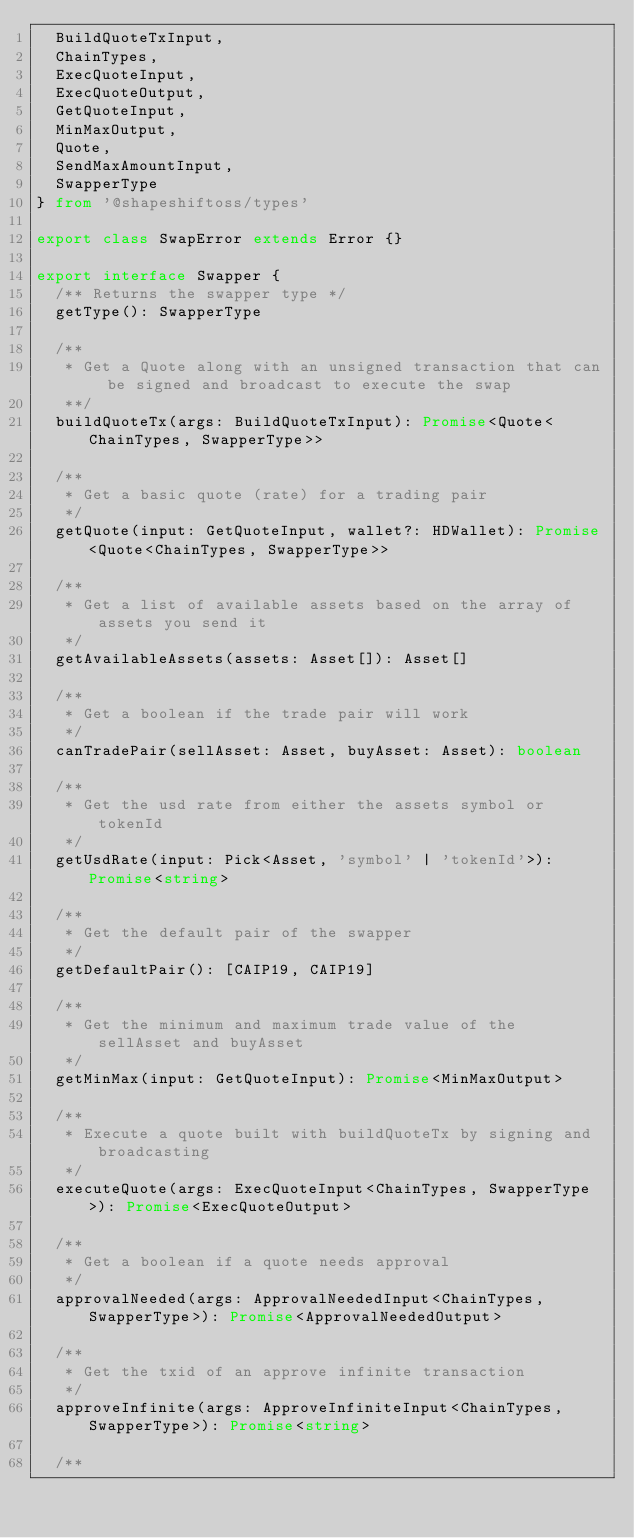<code> <loc_0><loc_0><loc_500><loc_500><_TypeScript_>  BuildQuoteTxInput,
  ChainTypes,
  ExecQuoteInput,
  ExecQuoteOutput,
  GetQuoteInput,
  MinMaxOutput,
  Quote,
  SendMaxAmountInput,
  SwapperType
} from '@shapeshiftoss/types'

export class SwapError extends Error {}

export interface Swapper {
  /** Returns the swapper type */
  getType(): SwapperType

  /**
   * Get a Quote along with an unsigned transaction that can be signed and broadcast to execute the swap
   **/
  buildQuoteTx(args: BuildQuoteTxInput): Promise<Quote<ChainTypes, SwapperType>>

  /**
   * Get a basic quote (rate) for a trading pair
   */
  getQuote(input: GetQuoteInput, wallet?: HDWallet): Promise<Quote<ChainTypes, SwapperType>>

  /**
   * Get a list of available assets based on the array of assets you send it
   */
  getAvailableAssets(assets: Asset[]): Asset[]

  /**
   * Get a boolean if the trade pair will work
   */
  canTradePair(sellAsset: Asset, buyAsset: Asset): boolean

  /**
   * Get the usd rate from either the assets symbol or tokenId
   */
  getUsdRate(input: Pick<Asset, 'symbol' | 'tokenId'>): Promise<string>

  /**
   * Get the default pair of the swapper
   */
  getDefaultPair(): [CAIP19, CAIP19]

  /**
   * Get the minimum and maximum trade value of the sellAsset and buyAsset
   */
  getMinMax(input: GetQuoteInput): Promise<MinMaxOutput>

  /**
   * Execute a quote built with buildQuoteTx by signing and broadcasting
   */
  executeQuote(args: ExecQuoteInput<ChainTypes, SwapperType>): Promise<ExecQuoteOutput>

  /**
   * Get a boolean if a quote needs approval
   */
  approvalNeeded(args: ApprovalNeededInput<ChainTypes, SwapperType>): Promise<ApprovalNeededOutput>

  /**
   * Get the txid of an approve infinite transaction
   */
  approveInfinite(args: ApproveInfiniteInput<ChainTypes, SwapperType>): Promise<string>

  /**</code> 